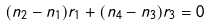Convert formula to latex. <formula><loc_0><loc_0><loc_500><loc_500>( n _ { 2 } - n _ { 1 } ) r _ { 1 } + ( n _ { 4 } - n _ { 3 } ) r _ { 3 } = 0</formula> 